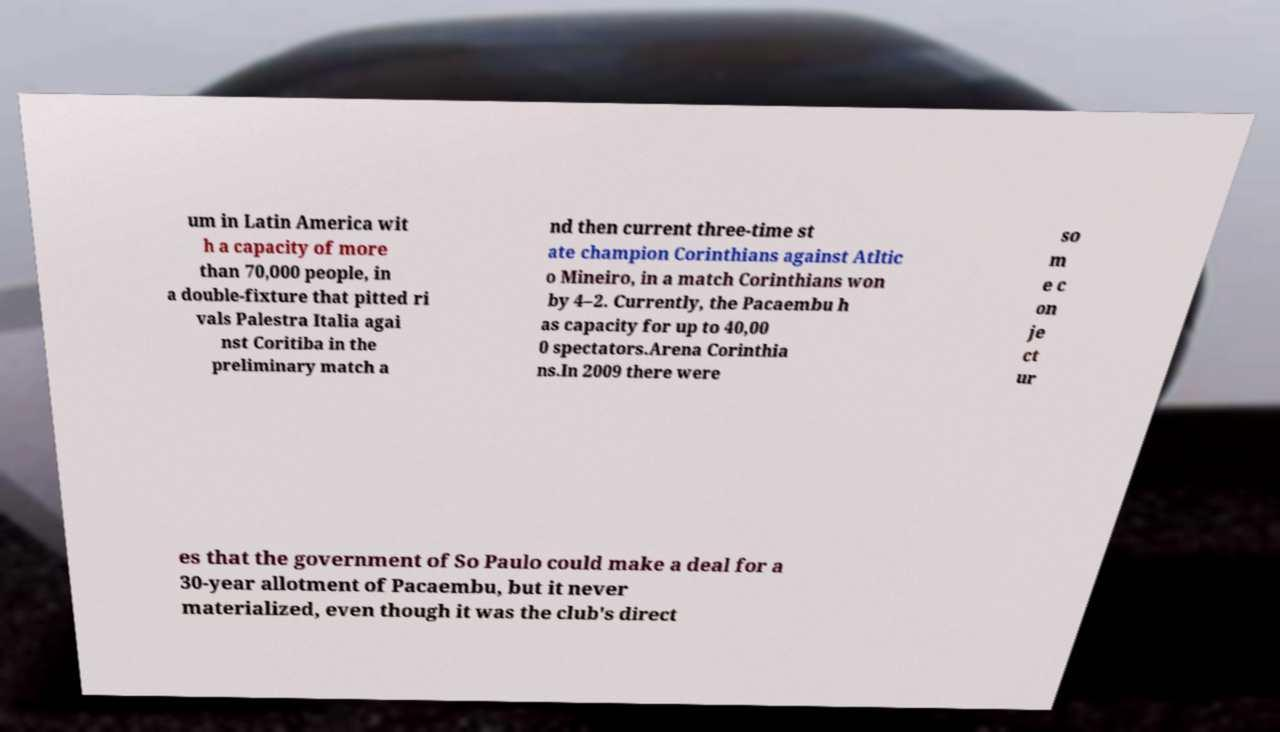Can you read and provide the text displayed in the image?This photo seems to have some interesting text. Can you extract and type it out for me? um in Latin America wit h a capacity of more than 70,000 people, in a double-fixture that pitted ri vals Palestra Italia agai nst Coritiba in the preliminary match a nd then current three-time st ate champion Corinthians against Atltic o Mineiro, in a match Corinthians won by 4–2. Currently, the Pacaembu h as capacity for up to 40,00 0 spectators.Arena Corinthia ns.In 2009 there were so m e c on je ct ur es that the government of So Paulo could make a deal for a 30-year allotment of Pacaembu, but it never materialized, even though it was the club's direct 